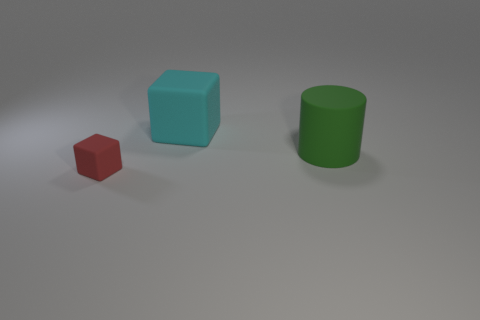Is there anything else that is the same size as the red cube?
Your answer should be compact. No. How big is the cube that is behind the matte block to the left of the large cyan rubber cube?
Ensure brevity in your answer.  Large. Are the thing in front of the big cylinder and the object behind the green cylinder made of the same material?
Provide a short and direct response. Yes. Is the color of the big matte object that is to the right of the large cyan rubber block the same as the small rubber thing?
Your answer should be compact. No. There is a small red matte object; what number of red things are in front of it?
Your answer should be very brief. 0. Are the tiny cube and the large object on the right side of the large matte block made of the same material?
Your answer should be compact. Yes. The cylinder that is made of the same material as the small red thing is what size?
Provide a succinct answer. Large. Are there more red objects that are to the left of the red block than big green things behind the cylinder?
Keep it short and to the point. No. Are there any tiny rubber objects of the same shape as the large cyan rubber object?
Your answer should be very brief. Yes. There is a object that is behind the matte cylinder; is its size the same as the green thing?
Provide a succinct answer. Yes. 